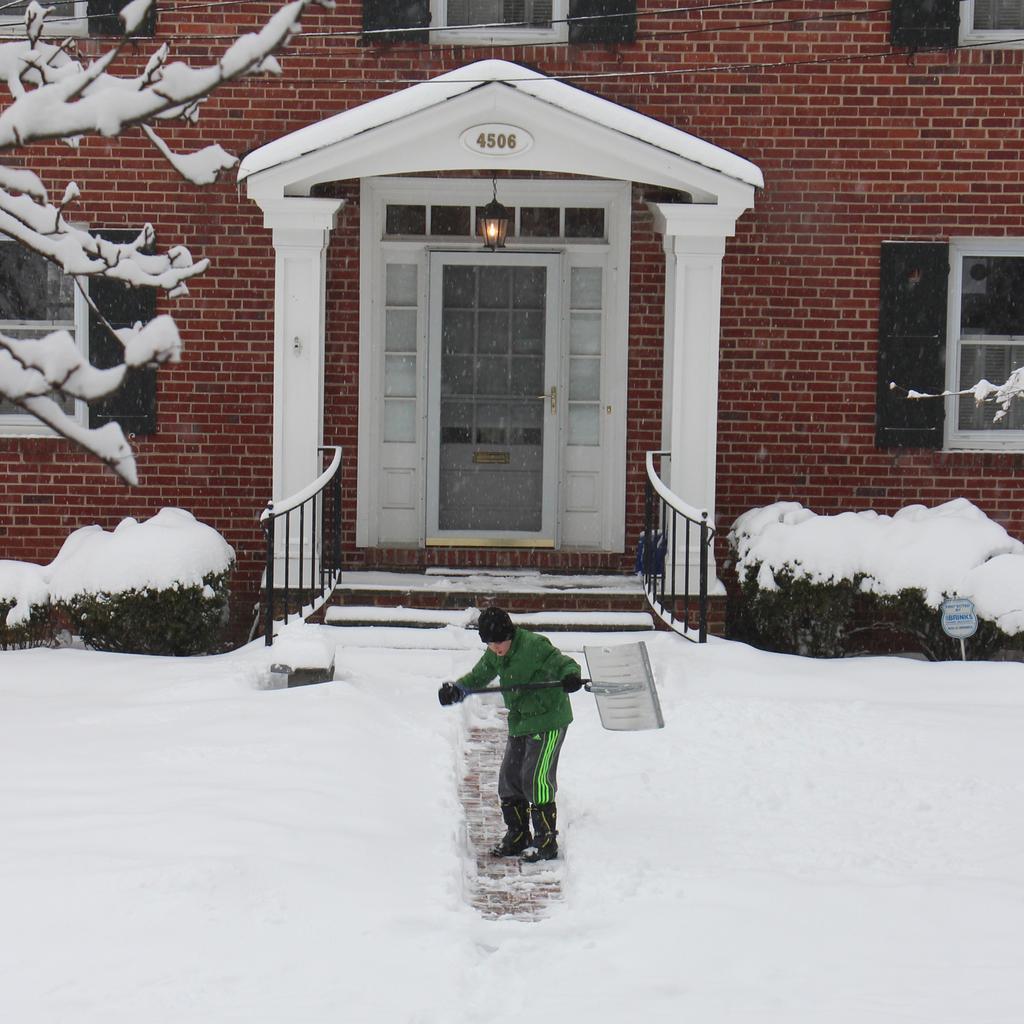Can you describe this image briefly? In this picture we can see a man, he is standing on the ice, and he is holding an object in his hands, in the background we can find few plants, trees, light and a house. 